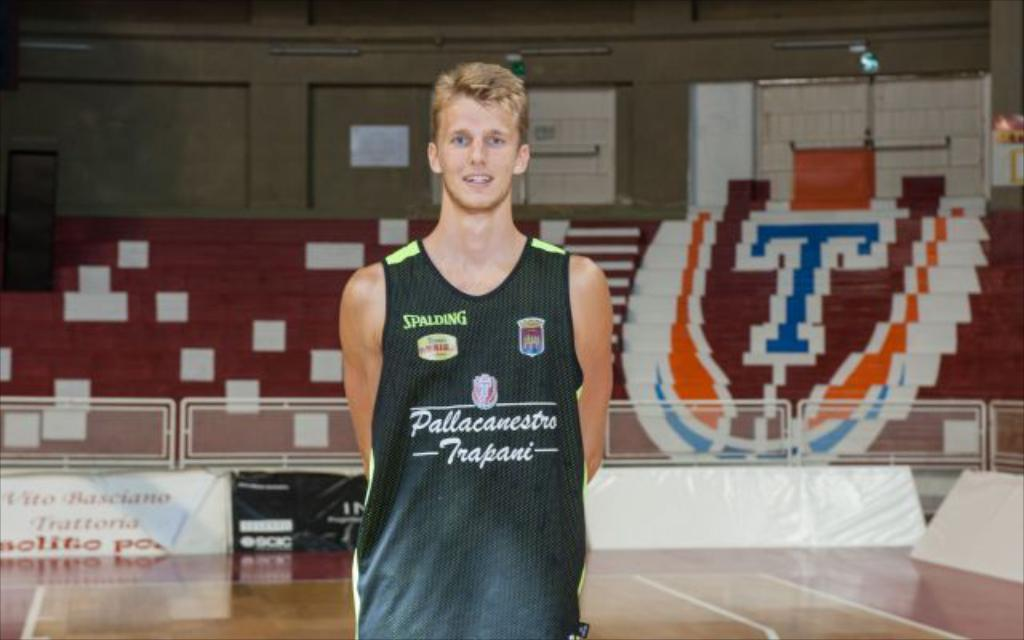<image>
Render a clear and concise summary of the photo. A man in a shirt that says Spalding stands in an indoor sports arena. 